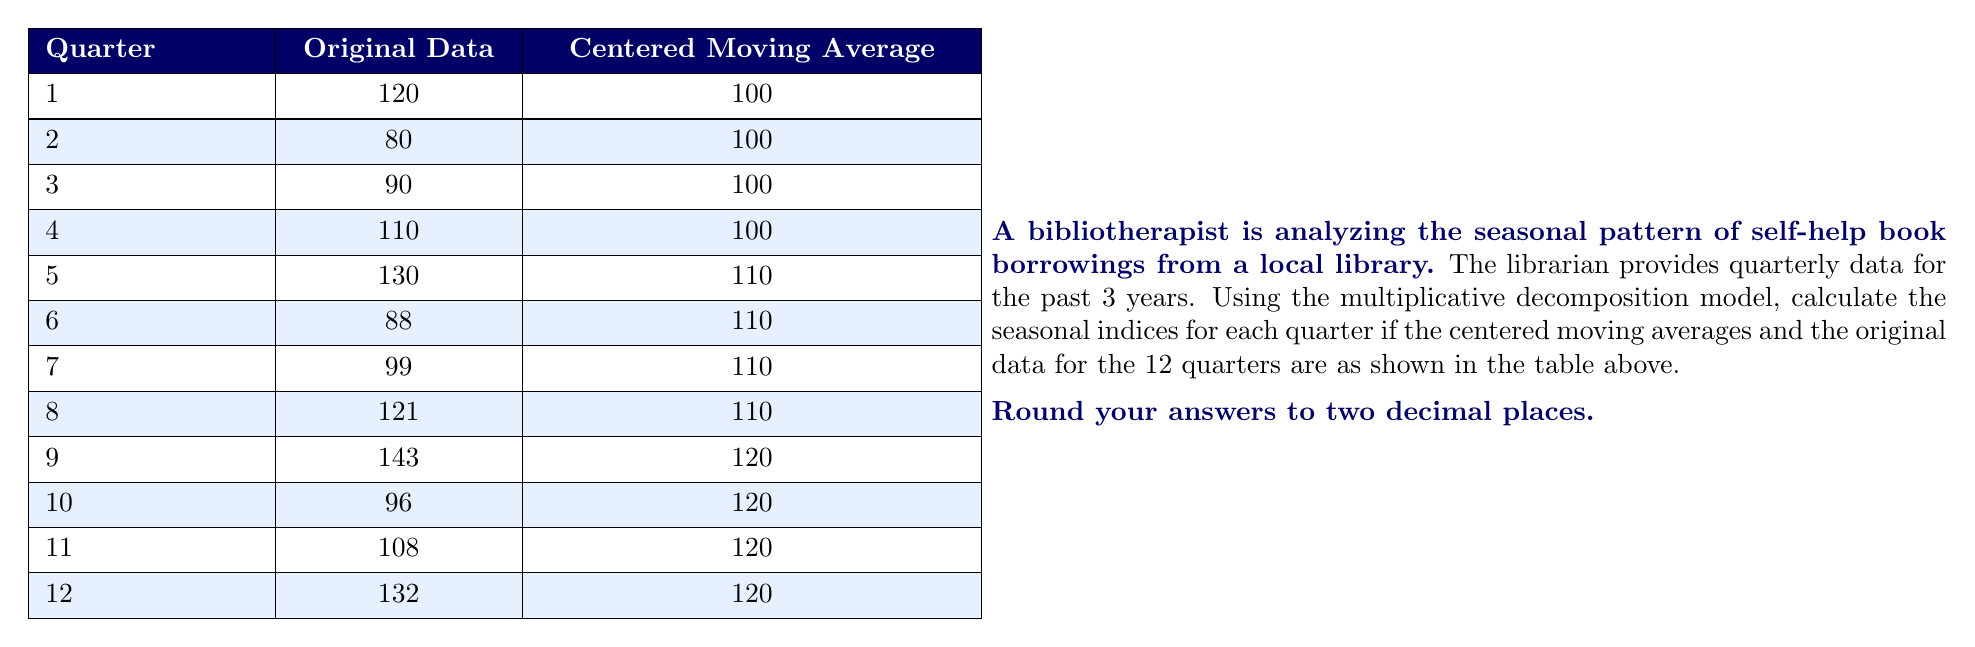What is the answer to this math problem? To calculate the seasonal indices using the multiplicative decomposition model, we follow these steps:

1) First, we calculate the seasonal-irregular component (SI) for each quarter by dividing the original data by the centered moving average:

   $SI = \frac{\text{Original Data}}{\text{Centered Moving Average}}$

2) Then, we group the SI values by quarter and calculate the average for each quarter:

   Quarter 1: $(120/100 + 130/110 + 143/120) / 3$
   Quarter 2: $(80/100 + 88/110 + 96/120) / 3$
   Quarter 3: $(90/100 + 99/110 + 108/120) / 3$
   Quarter 4: $(110/100 + 121/110 + 132/120) / 3$

3) These averages are our initial seasonal indices. Let's calculate them:

   Quarter 1: $(1.20 + 1.18 + 1.19) / 3 = 1.19$
   Quarter 2: $(0.80 + 0.80 + 0.80) / 3 = 0.80$
   Quarter 3: $(0.90 + 0.90 + 0.90) / 3 = 0.90$
   Quarter 4: $(1.10 + 1.10 + 1.10) / 3 = 1.10$

4) In a perfect multiplicative model, these indices should sum to 4 (because there are 4 quarters). We need to adjust them so they sum to 4:

   Current sum: $1.19 + 0.80 + 0.90 + 1.10 = 3.99$

   Adjustment factor: $4 / 3.99 = 1.0025$

5) We multiply each initial index by this adjustment factor to get our final seasonal indices:

   Quarter 1: $1.19 * 1.0025 = 1.1930$
   Quarter 2: $0.80 * 1.0025 = 0.8020$
   Quarter 3: $0.90 * 1.0025 = 0.9023$
   Quarter 4: $1.10 * 1.0025 = 1.1028$

6) Rounding to two decimal places gives us our final answer.
Answer: The seasonal indices for each quarter are:
Quarter 1: 1.19
Quarter 2: 0.80
Quarter 3: 0.90
Quarter 4: 1.10 